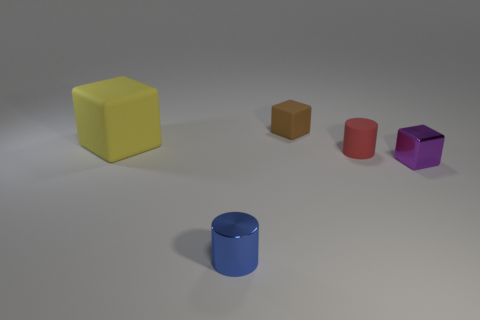Subtract all yellow cubes. How many cubes are left? 2 Subtract all tiny brown rubber blocks. How many blocks are left? 2 Subtract all yellow cylinders. How many yellow cubes are left? 1 Add 3 tiny purple cubes. How many tiny purple cubes exist? 4 Add 5 tiny blue cylinders. How many objects exist? 10 Subtract 0 blue spheres. How many objects are left? 5 Subtract all blocks. How many objects are left? 2 Subtract 3 blocks. How many blocks are left? 0 Subtract all purple blocks. Subtract all blue balls. How many blocks are left? 2 Subtract all green objects. Subtract all blue metallic objects. How many objects are left? 4 